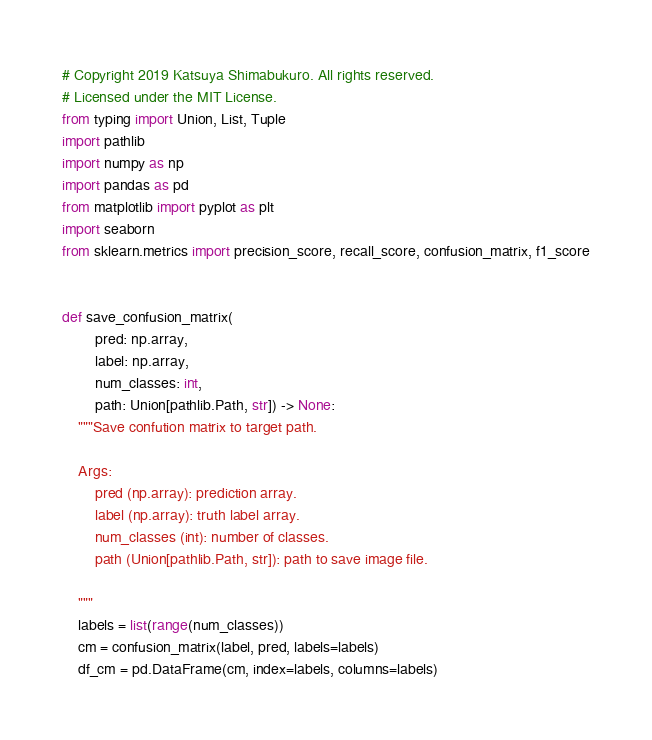Convert code to text. <code><loc_0><loc_0><loc_500><loc_500><_Python_># Copyright 2019 Katsuya Shimabukuro. All rights reserved.
# Licensed under the MIT License.
from typing import Union, List, Tuple
import pathlib
import numpy as np
import pandas as pd
from matplotlib import pyplot as plt
import seaborn
from sklearn.metrics import precision_score, recall_score, confusion_matrix, f1_score


def save_confusion_matrix(
        pred: np.array,
        label: np.array,
        num_classes: int,
        path: Union[pathlib.Path, str]) -> None:
    """Save confution matrix to target path.

    Args:
        pred (np.array): prediction array.
        label (np.array): truth label array.
        num_classes (int): number of classes.
        path (Union[pathlib.Path, str]): path to save image file.

    """
    labels = list(range(num_classes))
    cm = confusion_matrix(label, pred, labels=labels)
    df_cm = pd.DataFrame(cm, index=labels, columns=labels)</code> 